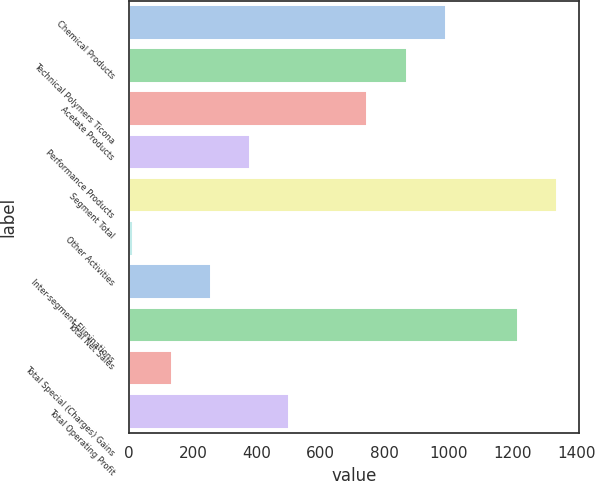Convert chart to OTSL. <chart><loc_0><loc_0><loc_500><loc_500><bar_chart><fcel>Chemical Products<fcel>Technical Polymers Ticona<fcel>Acetate Products<fcel>Performance Products<fcel>Segment Total<fcel>Other Activities<fcel>Inter-segment Eliminations<fcel>Total Net Sales<fcel>Total Special (Charges) Gains<fcel>Total Operating Profit<nl><fcel>991<fcel>868.5<fcel>746<fcel>378.5<fcel>1340.5<fcel>11<fcel>256<fcel>1218<fcel>133.5<fcel>501<nl></chart> 